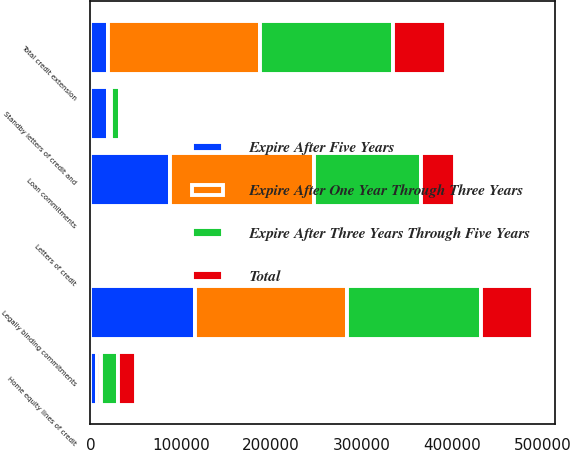Convert chart. <chart><loc_0><loc_0><loc_500><loc_500><stacked_bar_chart><ecel><fcel>Loan commitments<fcel>Home equity lines of credit<fcel>Standby letters of credit and<fcel>Letters of credit<fcel>Legally binding commitments<fcel>Total credit extension<nl><fcel>Expire After Five Years<fcel>87873<fcel>7074<fcel>19584<fcel>1650<fcel>116181<fcel>19697<nl><fcel>Expire After Three Years Through Five Years<fcel>119272<fcel>18438<fcel>9903<fcel>165<fcel>147778<fcel>147778<nl><fcel>Expire After One Year Through Three Years<fcel>158920<fcel>5126<fcel>3385<fcel>258<fcel>167689<fcel>167689<nl><fcel>Total<fcel>37112<fcel>19697<fcel>1218<fcel>54<fcel>58081<fcel>58081<nl></chart> 